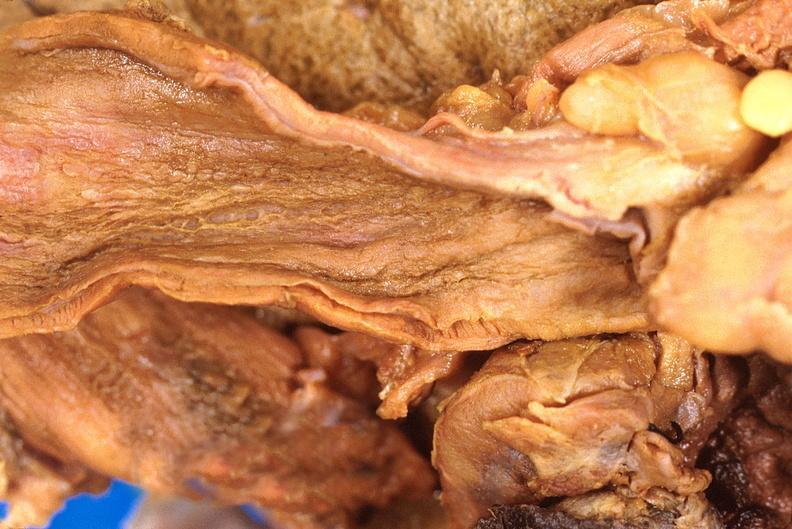s slide present?
Answer the question using a single word or phrase. No 